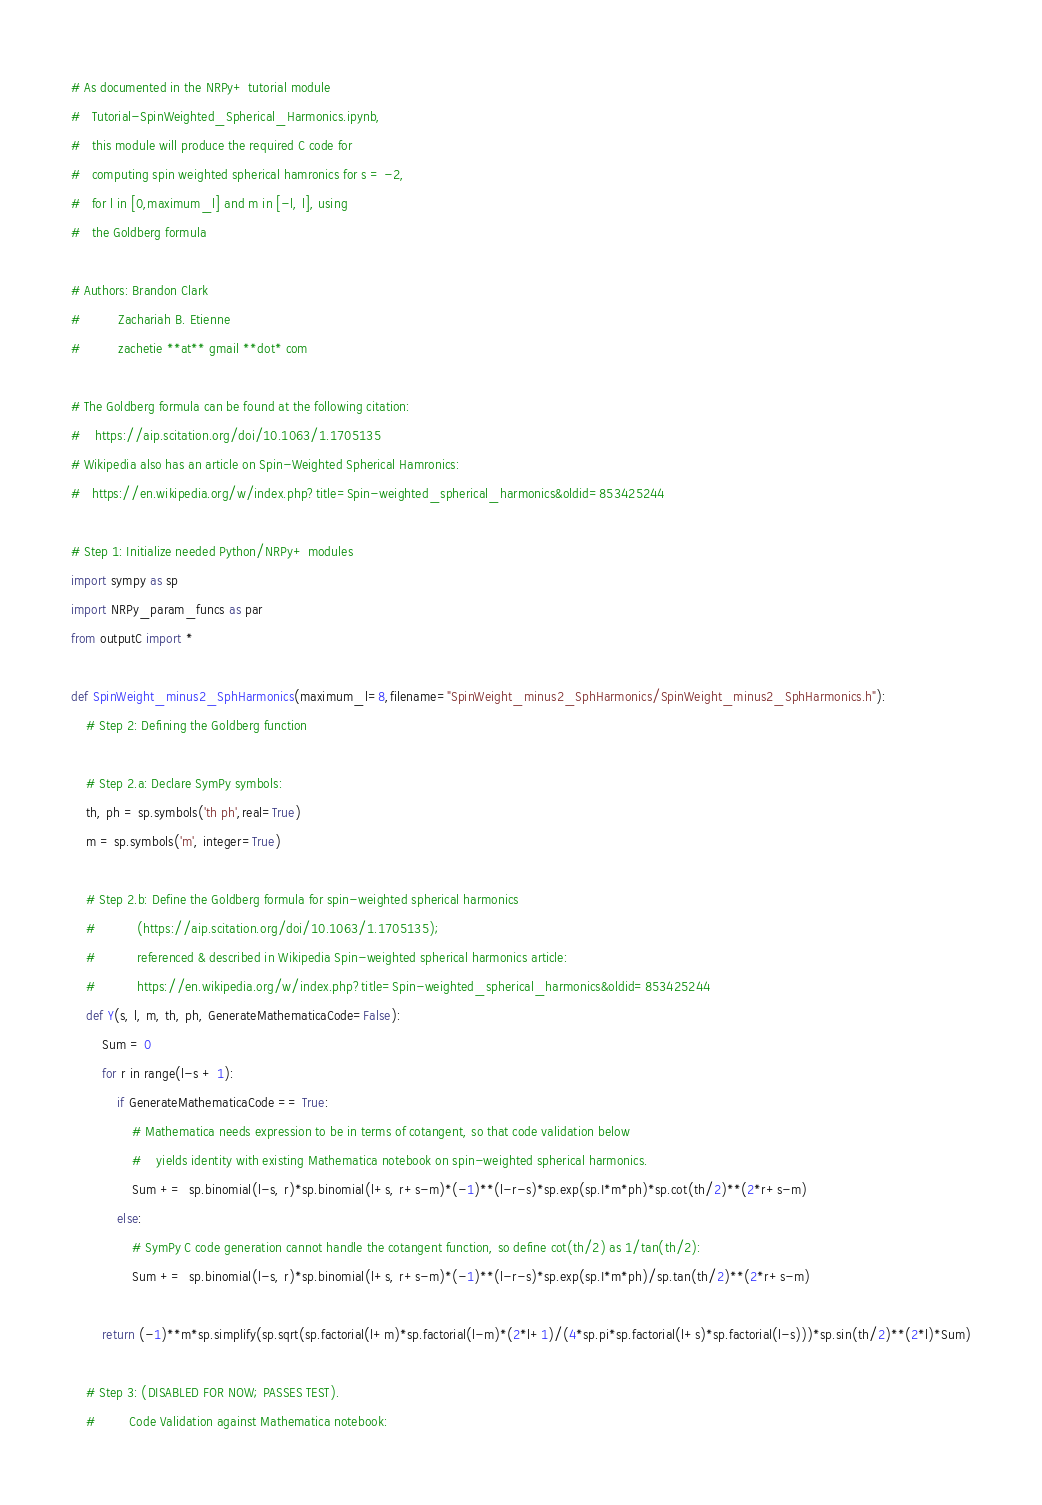Convert code to text. <code><loc_0><loc_0><loc_500><loc_500><_Python_># As documented in the NRPy+ tutorial module
#   Tutorial-SpinWeighted_Spherical_Harmonics.ipynb,
#   this module will produce the required C code for
#   computing spin weighted spherical hamronics for s = -2,
#   for l in [0,maximum_l] and m in [-l, l], using
#   the Goldberg formula

# Authors: Brandon Clark
#          Zachariah B. Etienne
#          zachetie **at** gmail **dot* com

# The Goldberg formula can be found at the following citation:
#    https://aip.scitation.org/doi/10.1063/1.1705135
# Wikipedia also has an article on Spin-Weighted Spherical Hamronics:
#   https://en.wikipedia.org/w/index.php?title=Spin-weighted_spherical_harmonics&oldid=853425244

# Step 1: Initialize needed Python/NRPy+ modules 
import sympy as sp
import NRPy_param_funcs as par
from outputC import *

def SpinWeight_minus2_SphHarmonics(maximum_l=8,filename="SpinWeight_minus2_SphHarmonics/SpinWeight_minus2_SphHarmonics.h"):
    # Step 2: Defining the Goldberg function

    # Step 2.a: Declare SymPy symbols:
    th, ph = sp.symbols('th ph',real=True)
    m = sp.symbols('m', integer=True)

    # Step 2.b: Define the Goldberg formula for spin-weighted spherical harmonics
    #           (https://aip.scitation.org/doi/10.1063/1.1705135);
    #           referenced & described in Wikipedia Spin-weighted spherical harmonics article:
    #           https://en.wikipedia.org/w/index.php?title=Spin-weighted_spherical_harmonics&oldid=853425244
    def Y(s, l, m, th, ph, GenerateMathematicaCode=False):
        Sum = 0
        for r in range(l-s + 1):
            if GenerateMathematicaCode == True:
                # Mathematica needs expression to be in terms of cotangent, so that code validation below
                #    yields identity with existing Mathematica notebook on spin-weighted spherical harmonics.
                Sum +=  sp.binomial(l-s, r)*sp.binomial(l+s, r+s-m)*(-1)**(l-r-s)*sp.exp(sp.I*m*ph)*sp.cot(th/2)**(2*r+s-m)
            else:
                # SymPy C code generation cannot handle the cotangent function, so define cot(th/2) as 1/tan(th/2):
                Sum +=  sp.binomial(l-s, r)*sp.binomial(l+s, r+s-m)*(-1)**(l-r-s)*sp.exp(sp.I*m*ph)/sp.tan(th/2)**(2*r+s-m)

        return (-1)**m*sp.simplify(sp.sqrt(sp.factorial(l+m)*sp.factorial(l-m)*(2*l+1)/(4*sp.pi*sp.factorial(l+s)*sp.factorial(l-s)))*sp.sin(th/2)**(2*l)*Sum)

    # Step 3: (DISABLED FOR NOW; PASSES TEST). 
    #         Code Validation against Mathematica notebook:</code> 